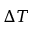Convert formula to latex. <formula><loc_0><loc_0><loc_500><loc_500>\Delta T</formula> 